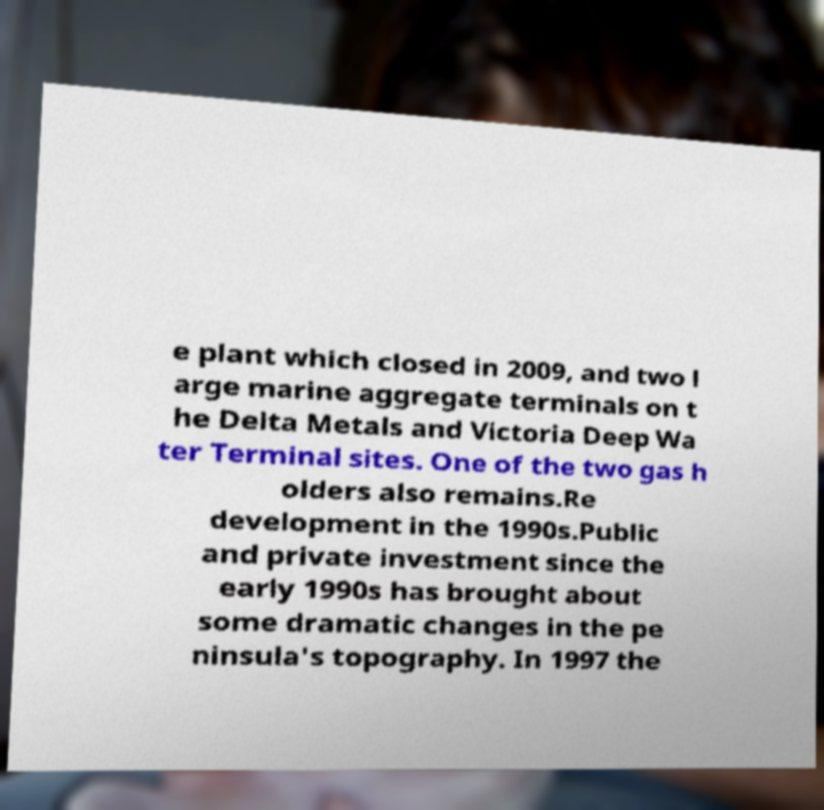For documentation purposes, I need the text within this image transcribed. Could you provide that? e plant which closed in 2009, and two l arge marine aggregate terminals on t he Delta Metals and Victoria Deep Wa ter Terminal sites. One of the two gas h olders also remains.Re development in the 1990s.Public and private investment since the early 1990s has brought about some dramatic changes in the pe ninsula's topography. In 1997 the 